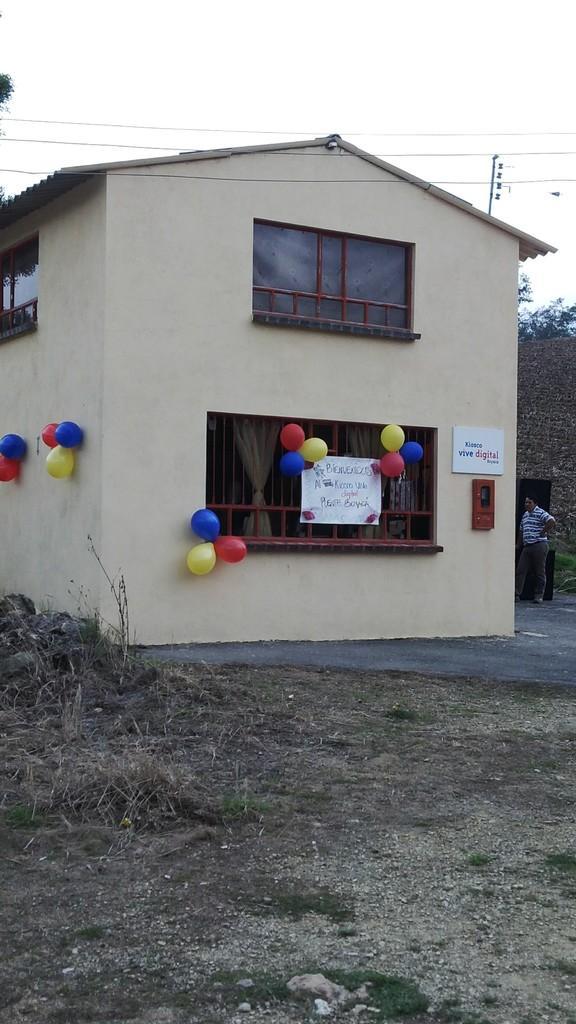In one or two sentences, can you explain what this image depicts? In this picture we can see a house, balloons, poster, curtains, windows, and a board. There is a person. In the background there is sky. 